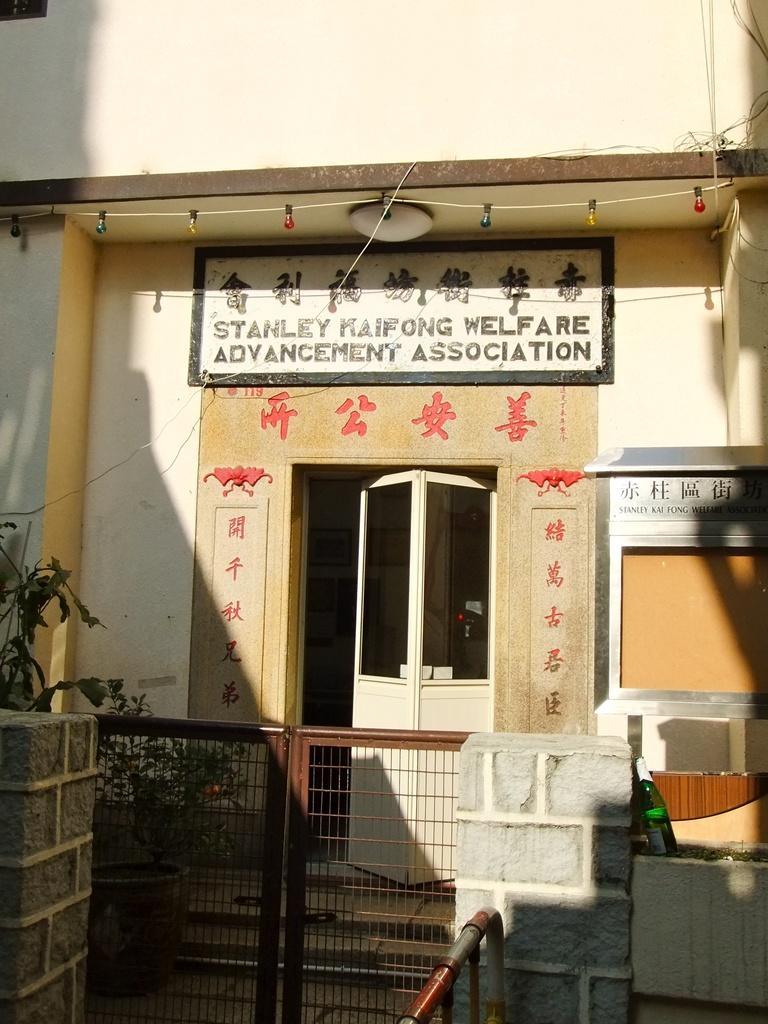Please provide a concise description of this image. In this picture there is a building with a door and some name plate on this. There is a gate in front of it 